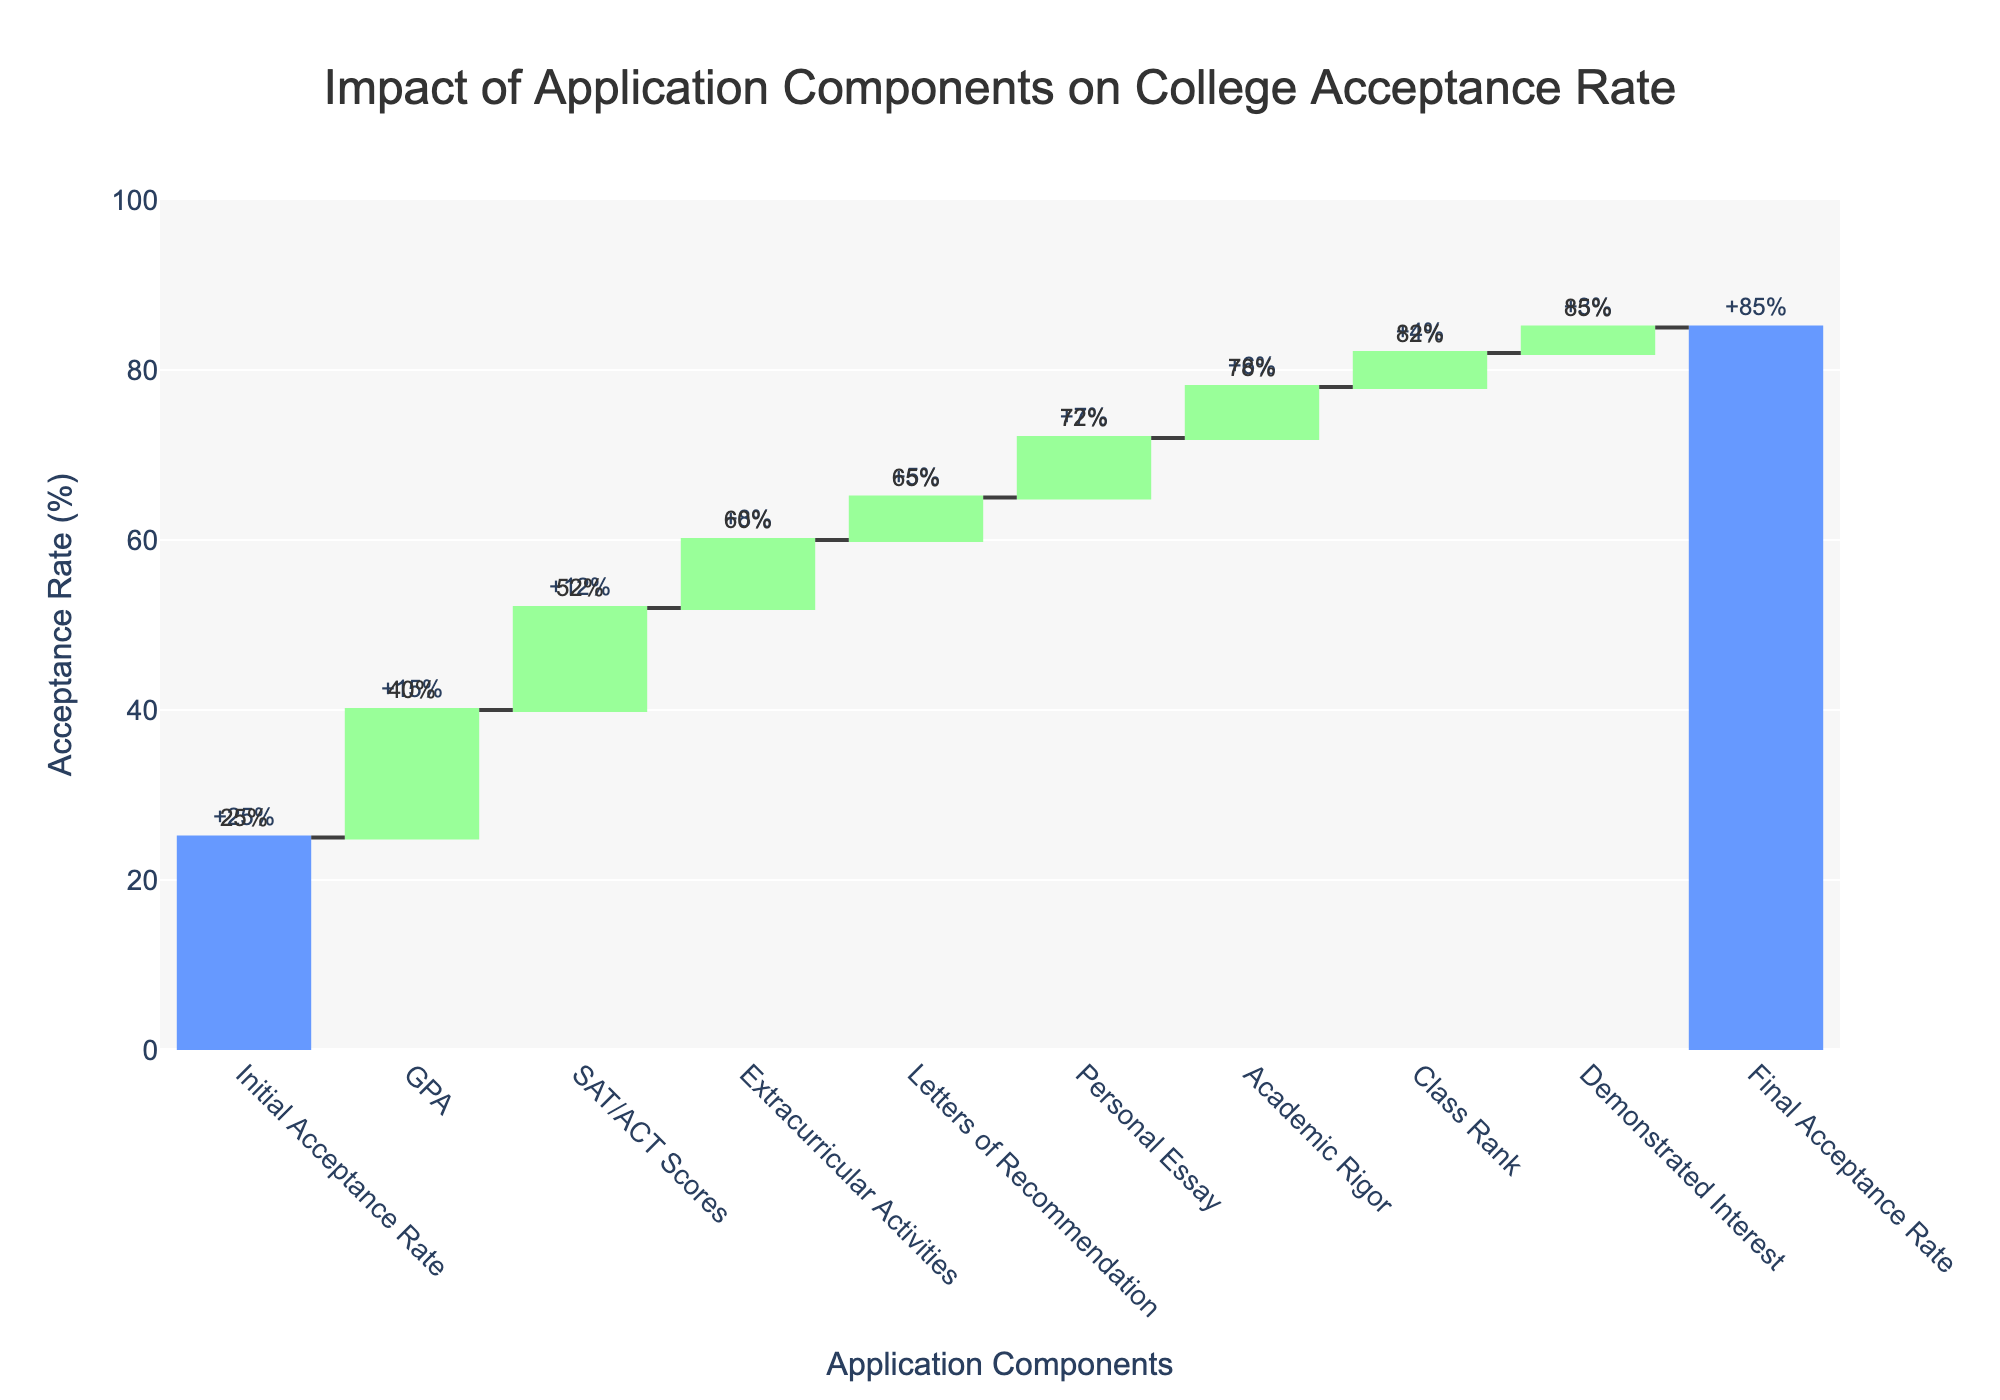What's the title of the chart? The title of the chart is found at the top and provides a summary of the subject being illustrated. The title is "Impact of Application Components on College Acceptance Rate."
Answer: Impact of Application Components on College Acceptance Rate What is the initial acceptance rate? The initial acceptance rate is the first data point in the waterfall chart, which stands for the starting value before any other components are considered. The initial acceptance rate is shown as 25%.
Answer: 25% Which component has the highest impact on acceptance rate? To find the component with the highest impact, you look for the highest single value in the "Impact" data. GPA has the highest impact, increasing the acceptance rate by 15%.
Answer: GPA How much does the final acceptance rate increase from the initial acceptance rate? To find the increase, subtract the initial acceptance rate from the final acceptance rate. The initial acceptance rate is 25%, and the final acceptance rate is 85%, so the increase is 85% - 25% = 60%.
Answer: 60% What's the total impact of test scores, extracurriculars, and essays combined? To calculate the total impact of SAT/ACT Scores, Extracurricular Activities, and Personal Essay, sum their respective impacts: 12% (SAT/ACT Scores) + 8% (Extracurricular Activities) + 7% (Personal Essay) = 27%.
Answer: 27% How does the impact of Academic Rigor compare to Class Rank? To compare the impacts of Academic Rigor and Class Rank, look at their respective impacts. Academic Rigor adds 6% while Class Rank adds 4%. Academic Rigor has a greater impact by 2%.
Answer: Academic Rigor has 2% more impact than Class Rank What is the impact of all application components excluding GPA? Subtract the impact of GPA from the total incremental increase from all components. All components together have an incremental impact of 85% - 25% = 60%. The impact excluding GPA is 60% - 15% = 45%.
Answer: 45% Which component contributes the least to the acceptance rate increase? Locate the component that has the smallest positive impact on the acceptance rate. Demonstrated Interest contributes the least with a 3% impact.
Answer: Demonstrated Interest By how much does the impact of SAT/ACT Scores exceed the impact of Personal Essay? To find the difference between the impacts of SAT/ACT Scores and Personal Essay, subtract the impact of Personal Essay from that of SAT/ACT Scores: 12% - 7% = 5%.
Answer: 5% What is the cumulative acceptance rate after Extracurricular Activities are considered? To find the cumulative acceptance rate after Extracurricular Activities, add the impacts of all previous components including Initial Acceptance Rate and Extracurricular Activities: 25% (Initial) + 15% (GPA) + 12% (SAT/ACT Scores) + 8% (Extracurricular Activities) = 60%.
Answer: 60% 